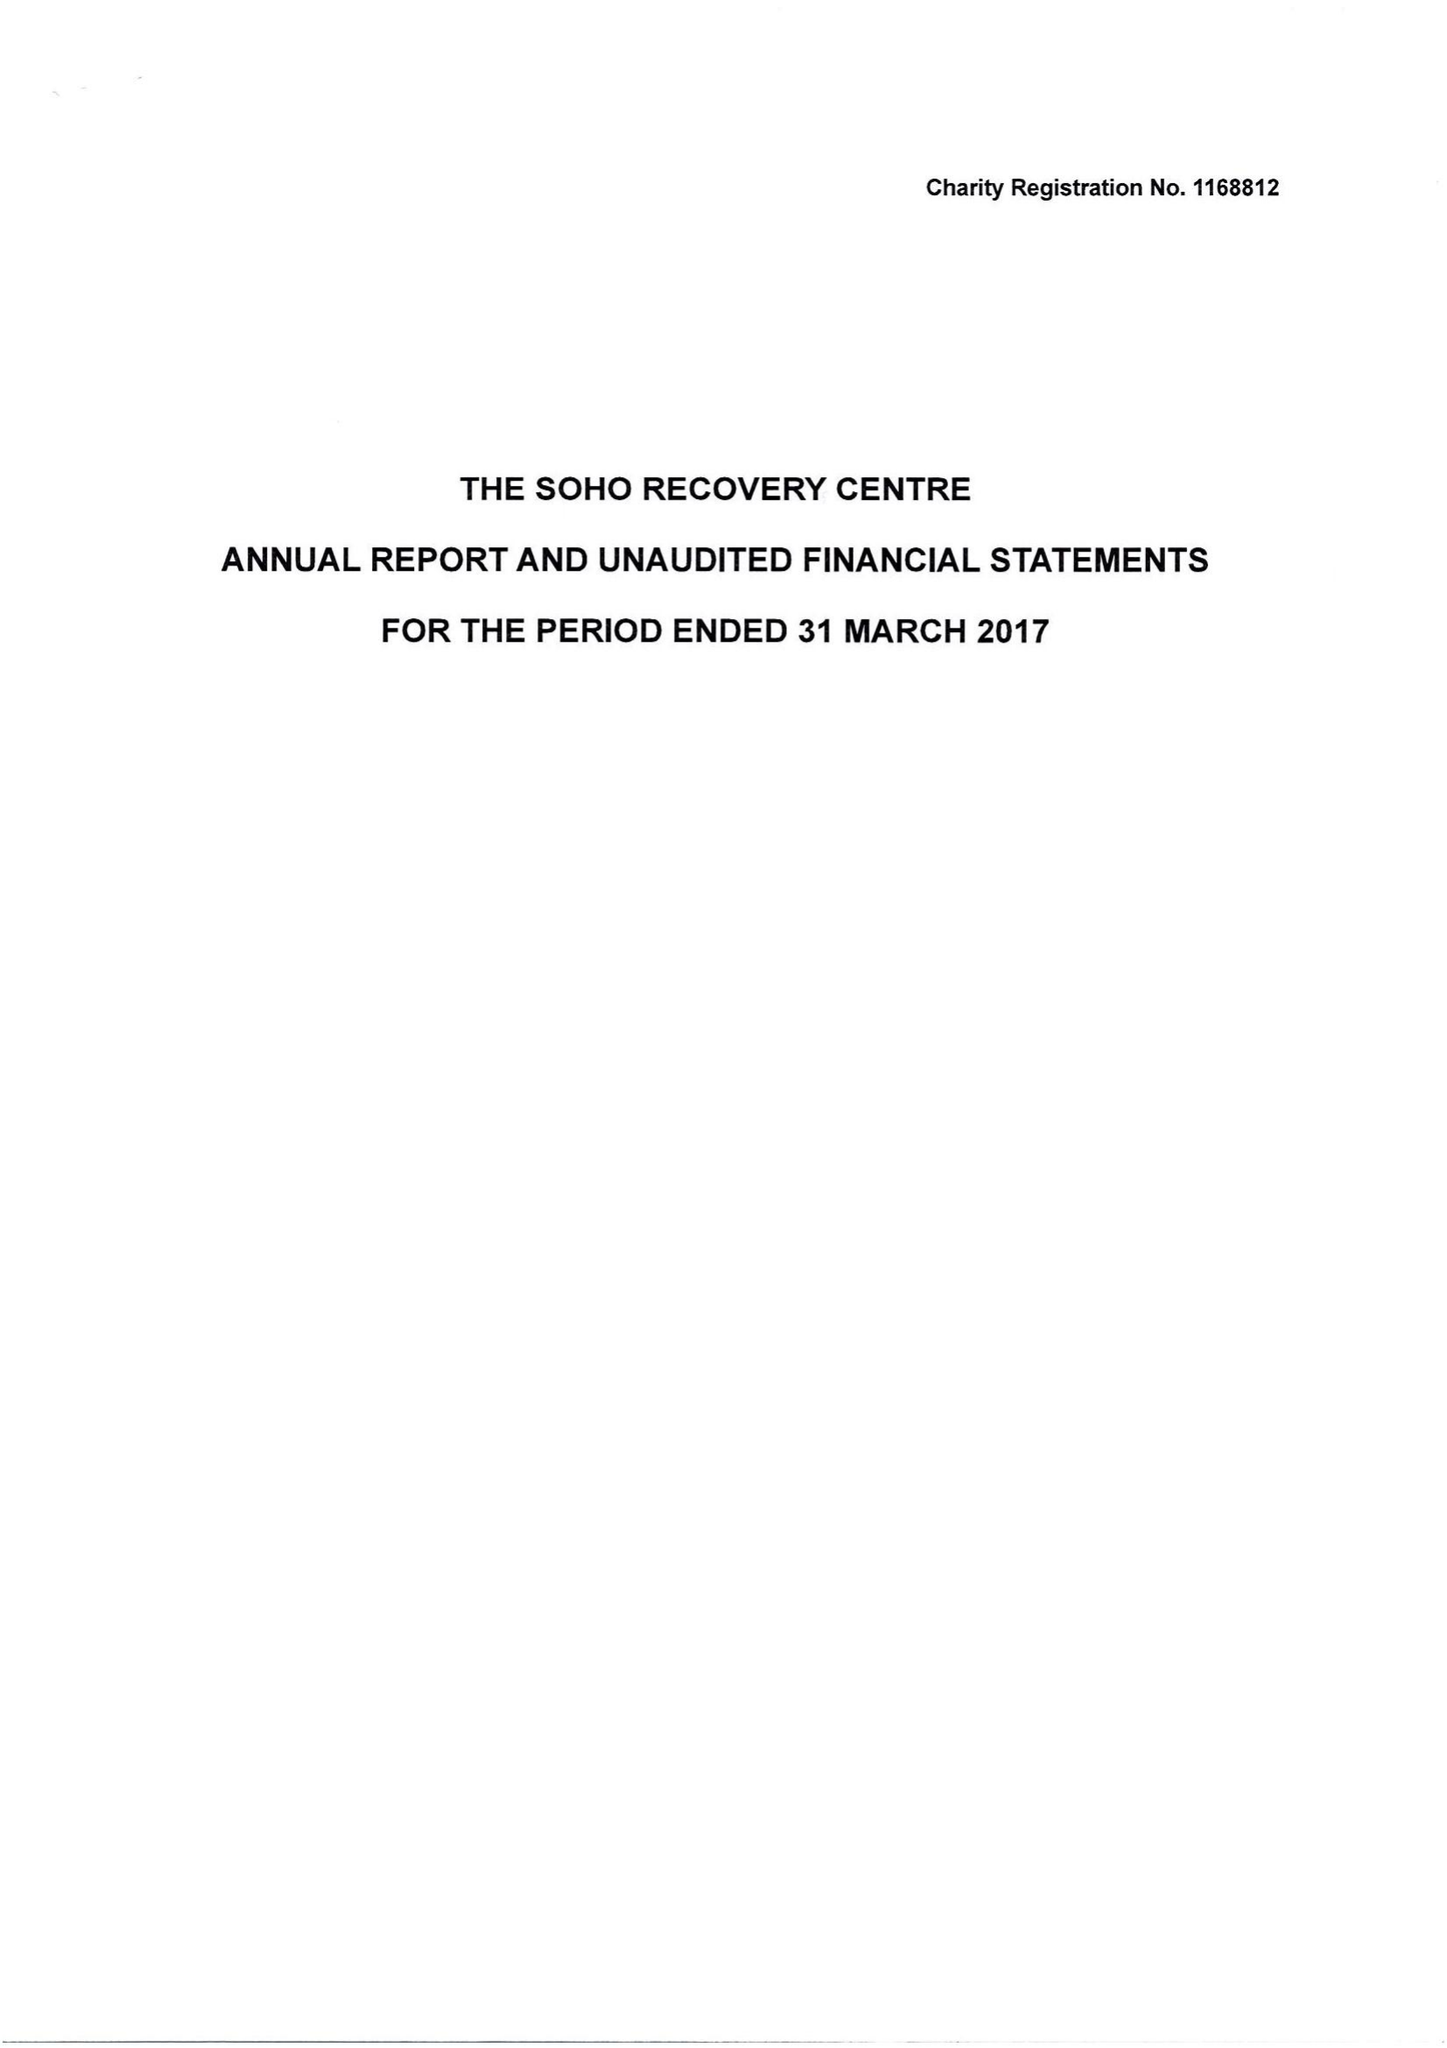What is the value for the income_annually_in_british_pounds?
Answer the question using a single word or phrase. 22503.00 